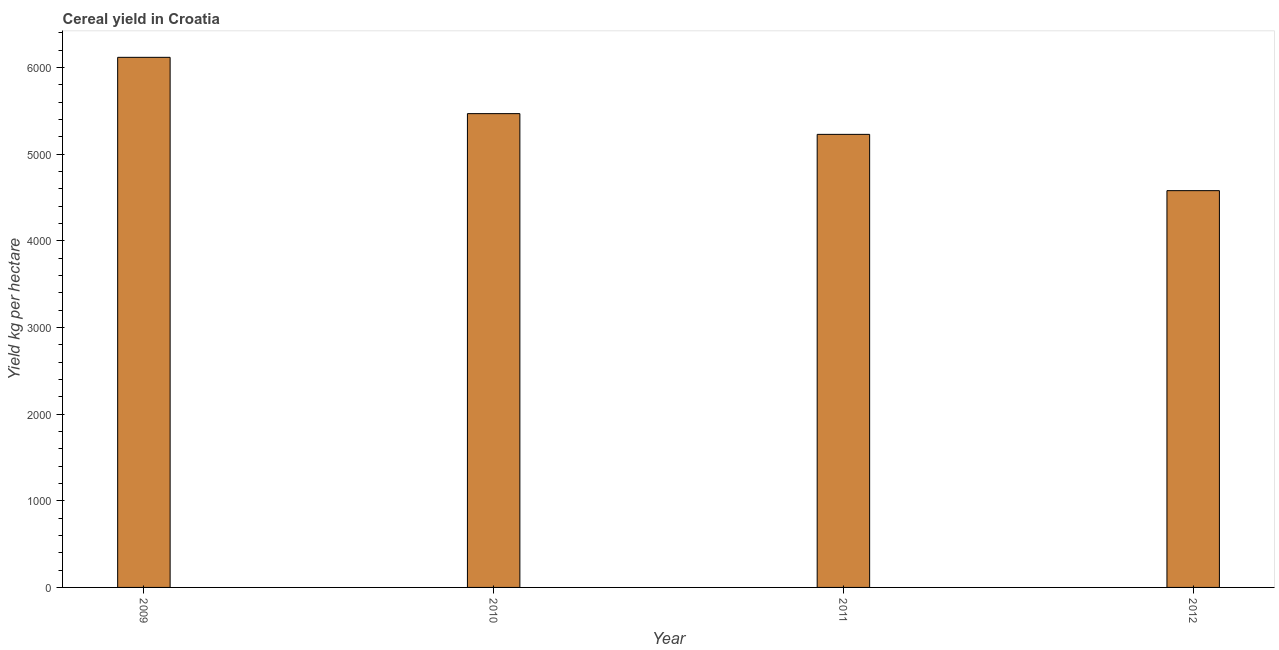What is the title of the graph?
Make the answer very short. Cereal yield in Croatia. What is the label or title of the X-axis?
Provide a succinct answer. Year. What is the label or title of the Y-axis?
Your answer should be compact. Yield kg per hectare. What is the cereal yield in 2009?
Offer a terse response. 6117.04. Across all years, what is the maximum cereal yield?
Your answer should be compact. 6117.04. Across all years, what is the minimum cereal yield?
Your response must be concise. 4578.66. In which year was the cereal yield maximum?
Your response must be concise. 2009. What is the sum of the cereal yield?
Your answer should be compact. 2.14e+04. What is the difference between the cereal yield in 2009 and 2011?
Offer a very short reply. 888.94. What is the average cereal yield per year?
Provide a short and direct response. 5347.8. What is the median cereal yield?
Provide a short and direct response. 5347.75. In how many years, is the cereal yield greater than 1400 kg per hectare?
Provide a succinct answer. 4. What is the ratio of the cereal yield in 2009 to that in 2010?
Keep it short and to the point. 1.12. Is the cereal yield in 2010 less than that in 2012?
Provide a succinct answer. No. What is the difference between the highest and the second highest cereal yield?
Ensure brevity in your answer.  649.64. What is the difference between the highest and the lowest cereal yield?
Give a very brief answer. 1538.37. In how many years, is the cereal yield greater than the average cereal yield taken over all years?
Your response must be concise. 2. How many bars are there?
Provide a succinct answer. 4. Are all the bars in the graph horizontal?
Your answer should be compact. No. How many years are there in the graph?
Your answer should be very brief. 4. What is the difference between two consecutive major ticks on the Y-axis?
Make the answer very short. 1000. What is the Yield kg per hectare in 2009?
Your answer should be compact. 6117.04. What is the Yield kg per hectare in 2010?
Your response must be concise. 5467.4. What is the Yield kg per hectare of 2011?
Your answer should be compact. 5228.1. What is the Yield kg per hectare in 2012?
Offer a very short reply. 4578.66. What is the difference between the Yield kg per hectare in 2009 and 2010?
Provide a short and direct response. 649.64. What is the difference between the Yield kg per hectare in 2009 and 2011?
Ensure brevity in your answer.  888.94. What is the difference between the Yield kg per hectare in 2009 and 2012?
Offer a very short reply. 1538.37. What is the difference between the Yield kg per hectare in 2010 and 2011?
Make the answer very short. 239.3. What is the difference between the Yield kg per hectare in 2010 and 2012?
Ensure brevity in your answer.  888.74. What is the difference between the Yield kg per hectare in 2011 and 2012?
Offer a very short reply. 649.43. What is the ratio of the Yield kg per hectare in 2009 to that in 2010?
Your answer should be very brief. 1.12. What is the ratio of the Yield kg per hectare in 2009 to that in 2011?
Ensure brevity in your answer.  1.17. What is the ratio of the Yield kg per hectare in 2009 to that in 2012?
Your response must be concise. 1.34. What is the ratio of the Yield kg per hectare in 2010 to that in 2011?
Your response must be concise. 1.05. What is the ratio of the Yield kg per hectare in 2010 to that in 2012?
Provide a short and direct response. 1.19. What is the ratio of the Yield kg per hectare in 2011 to that in 2012?
Offer a very short reply. 1.14. 